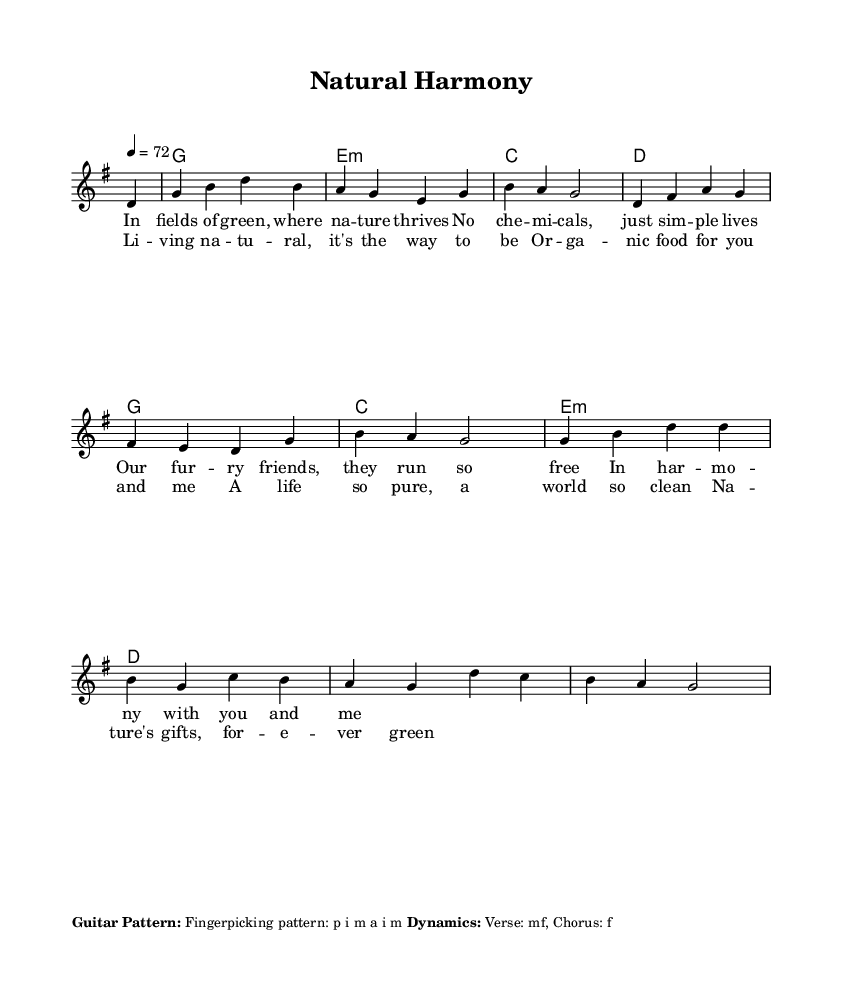What is the key signature of this music? The key signature is G major, which has one sharp (F#). The notation indicates a G major scale, defining the key.
Answer: G major What is the time signature of this piece? The time signature displayed at the beginning of the sheet music is 4/4, which means there are four beats in each measure and a quarter note gets one beat.
Answer: 4/4 What is the tempo marking for this song? The tempo is marked as "4 = 72," indicating that the quarter note should be played at a speed of 72 beats per minute. This is consistent with a moderate pace for folk music.
Answer: 72 How many measures are in the verse? The verse consists of 4 measures as indicated by the layout of the melody and lyrics. Counting the measures shown, it confirms four complete units of musical time.
Answer: 4 Which technique is suggested for guitar playing? The sheet music indicates a fingerpicking pattern described as "p i m a i m," which shows the recommended fingering for right-hand guitar technique.
Answer: Fingerpicking What dynamic marking is specified for the chorus? The dynamic marking for the chorus is "f," which indicates that this section should be played loudly. This is to emphasize the message of the song about natural living.
Answer: f What lyrical theme is present in this song? The song's lyrics focus on themes of nature, organic living, and a lifestyle free from chemicals. This reflects the song's overall message about harmony with nature.
Answer: Nature's harmony 